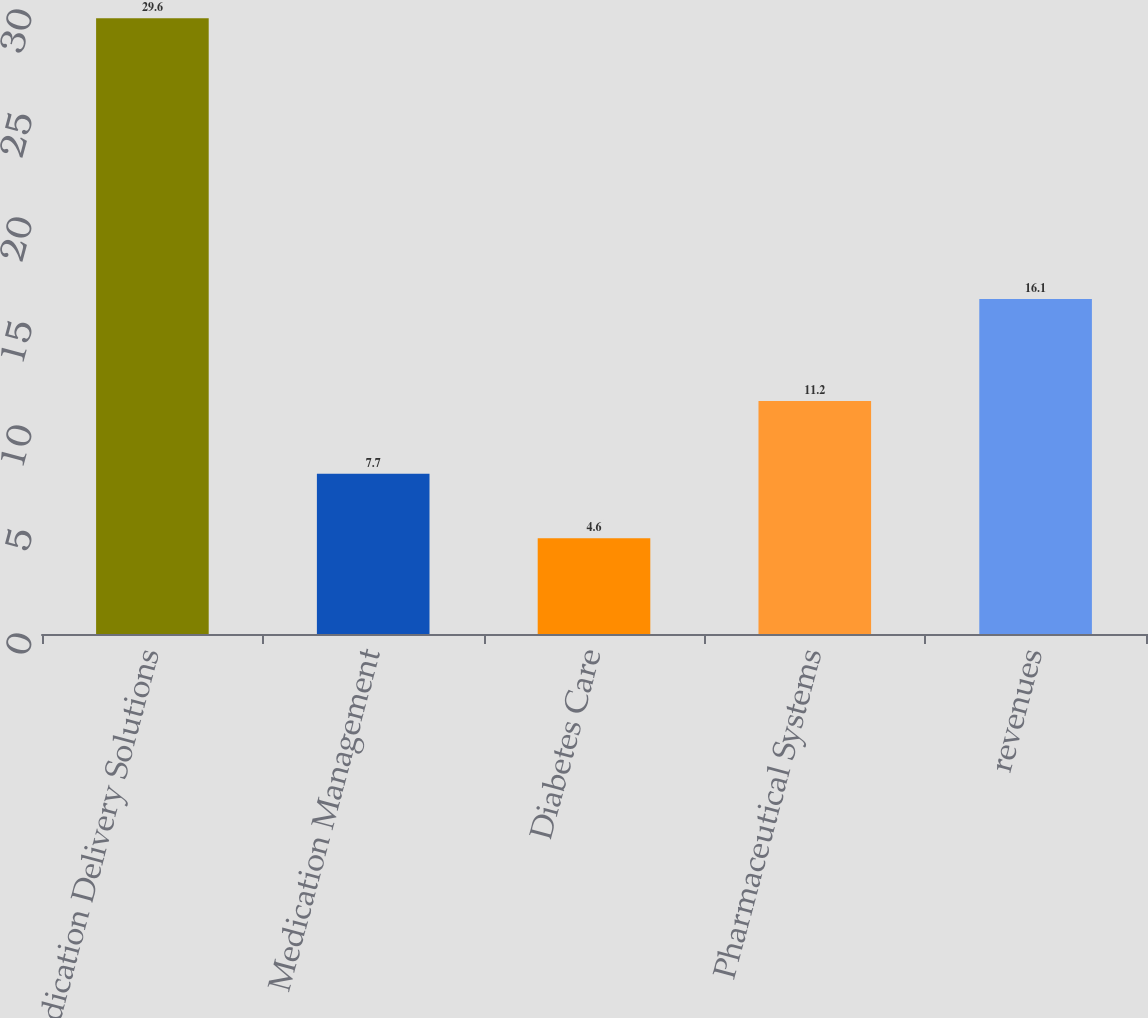<chart> <loc_0><loc_0><loc_500><loc_500><bar_chart><fcel>Medication Delivery Solutions<fcel>Medication Management<fcel>Diabetes Care<fcel>Pharmaceutical Systems<fcel>revenues<nl><fcel>29.6<fcel>7.7<fcel>4.6<fcel>11.2<fcel>16.1<nl></chart> 